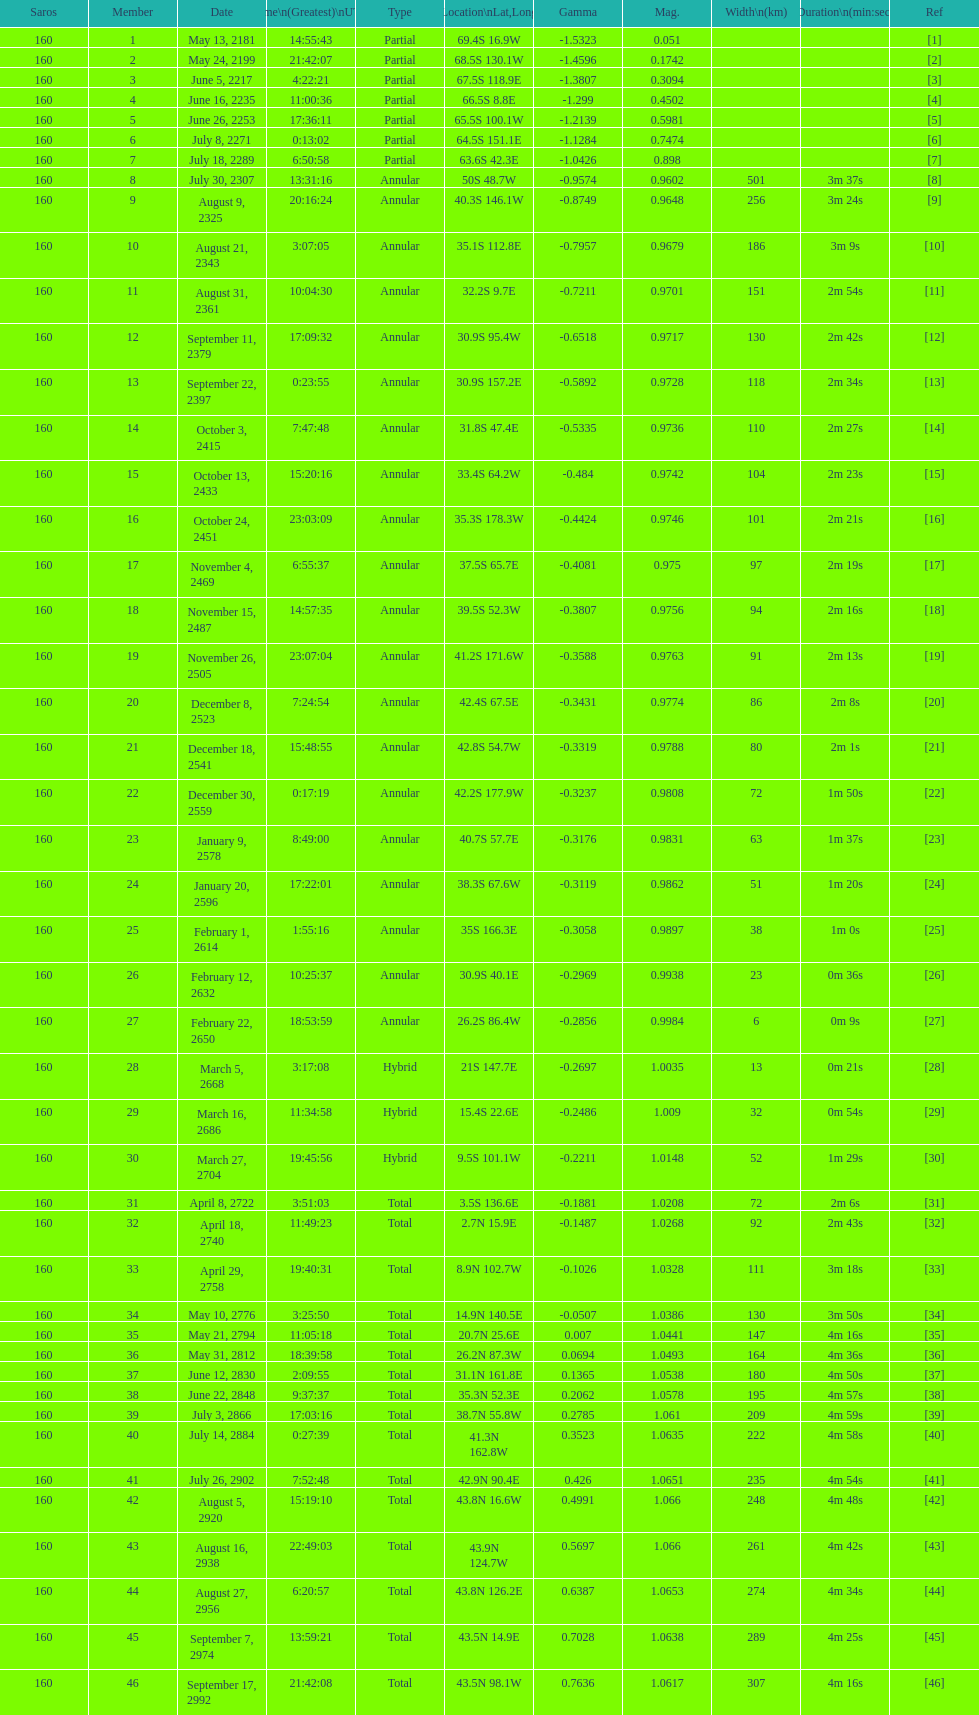Provide a member number located at a latitude exceeding 60 degrees in the southern hemisphere. 1. 